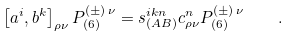Convert formula to latex. <formula><loc_0><loc_0><loc_500><loc_500>\left [ a ^ { i } , b ^ { k } \right ] _ { \rho \nu } P ^ { ( \pm ) \, \nu } _ { ( 6 ) } = s ^ { i k n } _ { ( A B ) } c ^ { n } _ { \rho \nu } P ^ { ( \pm ) \, \nu } _ { ( 6 ) } \quad .</formula> 